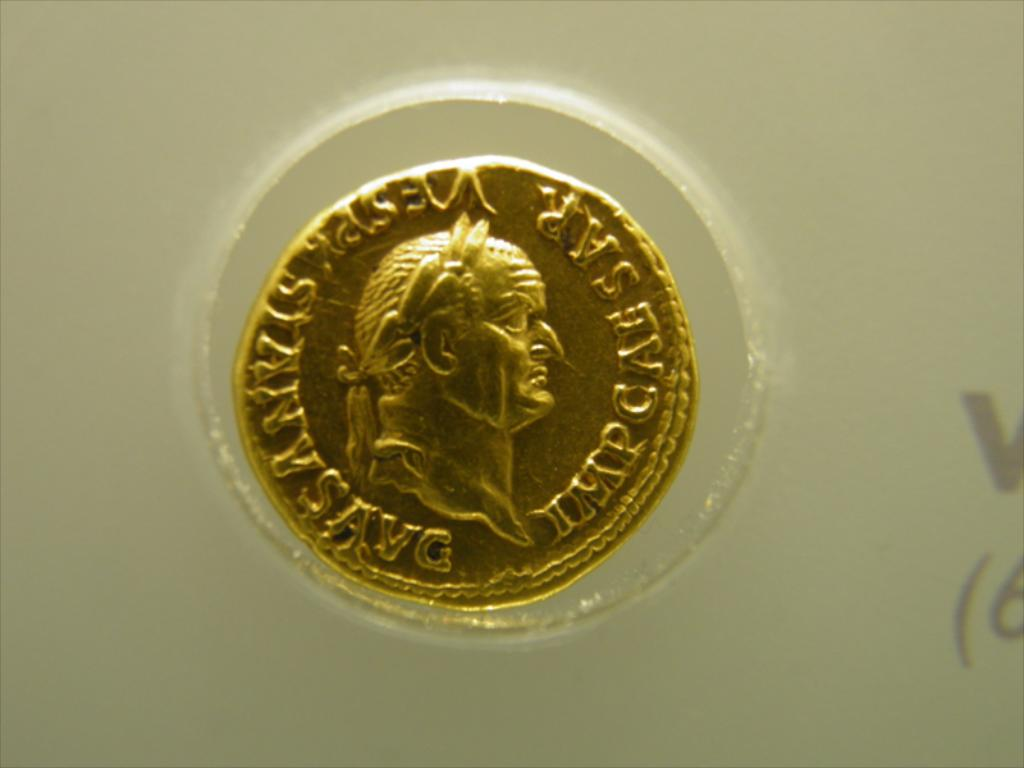How might the value of this coin compare to modern currencies, historically and in collector terms? Historically, this coin could represent a considerable sum depending on the era and region it circulated in. As a collector's item, its value would likely be enhanced by its condition, rarity, and historical significance, typically far surpassing its original face value in contemporary monetary terms. 